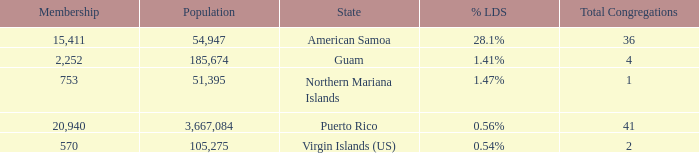What is Population, when Total Congregations is less than 4, and when % LDS is 0.54%? 105275.0. 